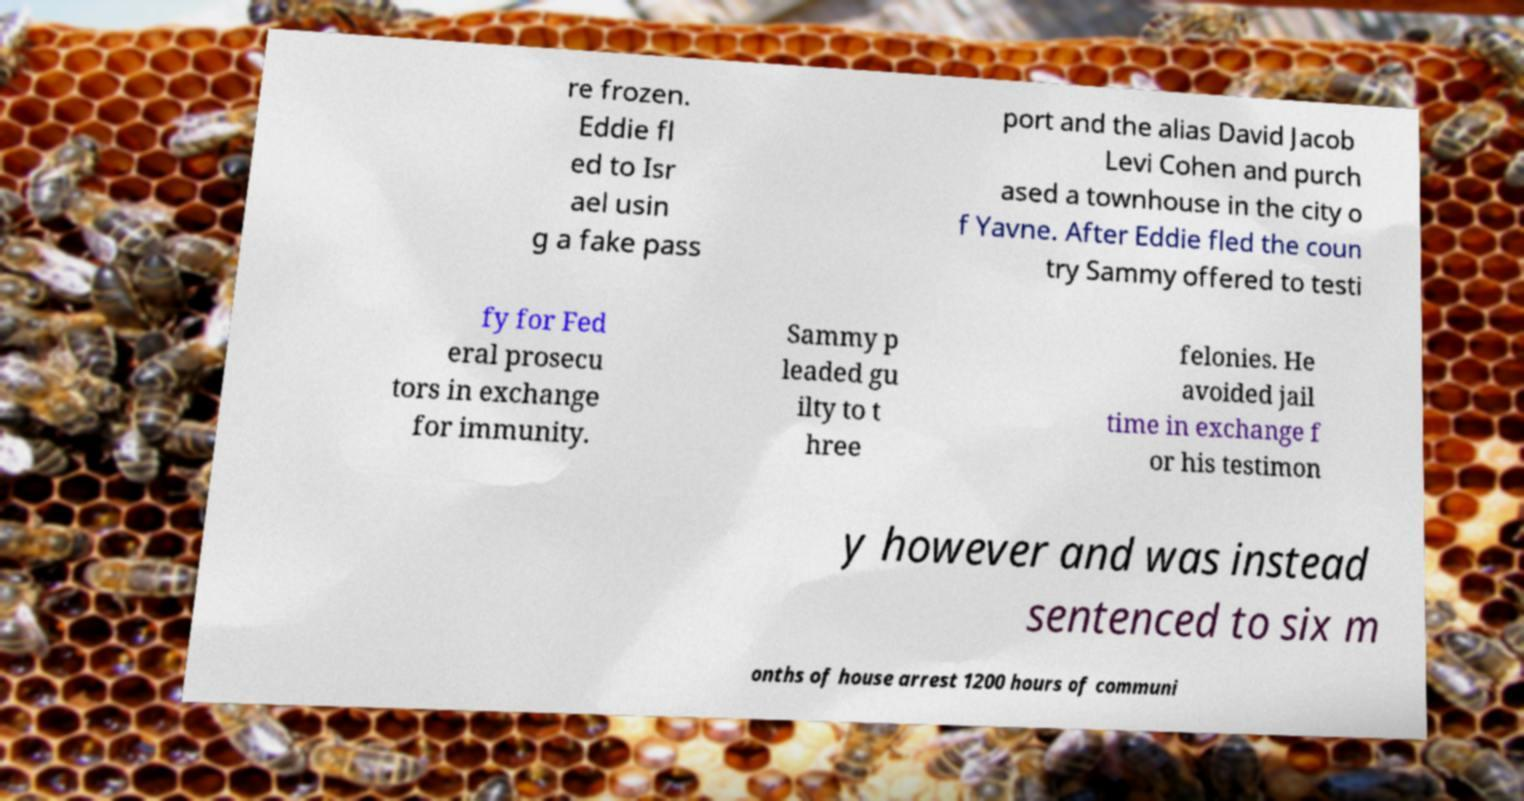Could you assist in decoding the text presented in this image and type it out clearly? re frozen. Eddie fl ed to Isr ael usin g a fake pass port and the alias David Jacob Levi Cohen and purch ased a townhouse in the city o f Yavne. After Eddie fled the coun try Sammy offered to testi fy for Fed eral prosecu tors in exchange for immunity. Sammy p leaded gu ilty to t hree felonies. He avoided jail time in exchange f or his testimon y however and was instead sentenced to six m onths of house arrest 1200 hours of communi 